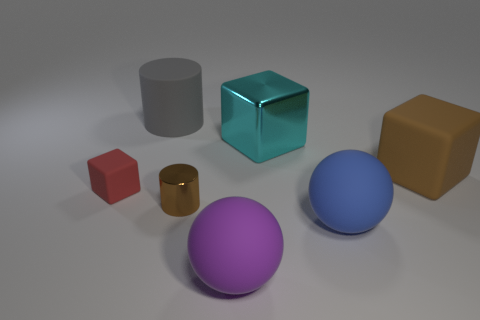Are there any blocks of the same color as the tiny metallic object?
Your response must be concise. Yes. Is there a gray metal block?
Your answer should be very brief. No. What color is the rubber cube right of the gray cylinder?
Make the answer very short. Brown. There is a purple rubber sphere; is its size the same as the block that is left of the purple ball?
Give a very brief answer. No. What is the size of the thing that is to the right of the gray rubber cylinder and to the left of the purple rubber thing?
Your answer should be compact. Small. Is there a large sphere that has the same material as the large gray cylinder?
Your answer should be very brief. Yes. The big cyan thing is what shape?
Provide a succinct answer. Cube. Does the cyan metal thing have the same size as the gray object?
Make the answer very short. Yes. How many other things are there of the same shape as the cyan thing?
Offer a very short reply. 2. There is a large thing behind the cyan shiny object; what is its shape?
Ensure brevity in your answer.  Cylinder. 